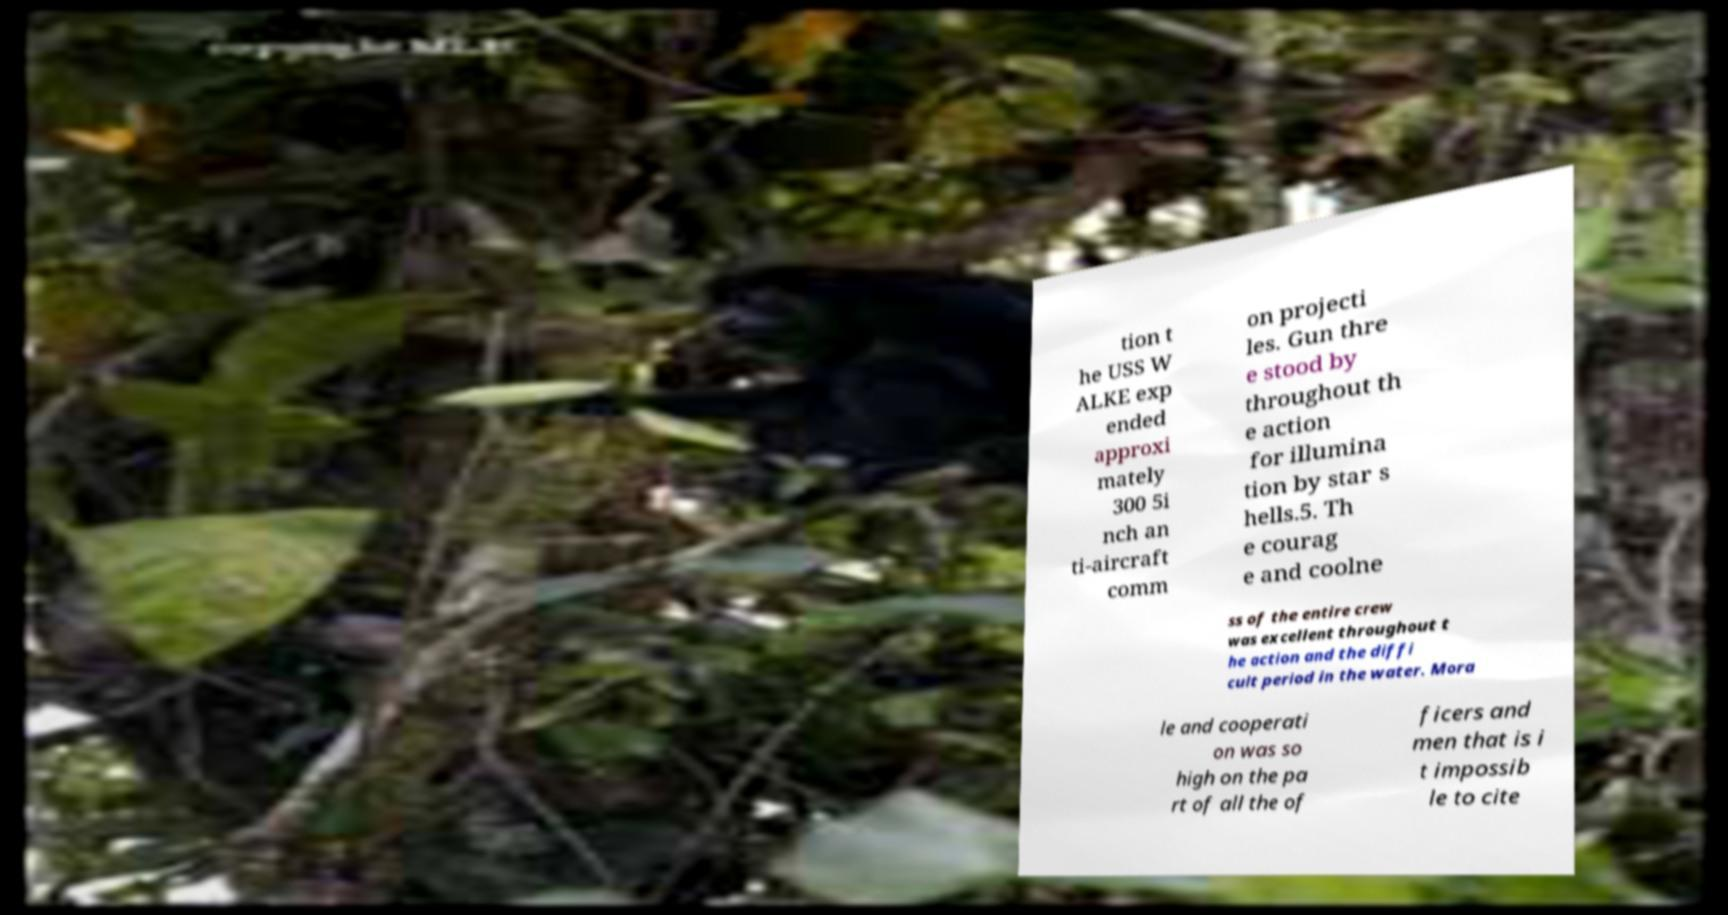Please read and relay the text visible in this image. What does it say? tion t he USS W ALKE exp ended approxi mately 300 5i nch an ti-aircraft comm on projecti les. Gun thre e stood by throughout th e action for illumina tion by star s hells.5. Th e courag e and coolne ss of the entire crew was excellent throughout t he action and the diffi cult period in the water. Mora le and cooperati on was so high on the pa rt of all the of ficers and men that is i t impossib le to cite 